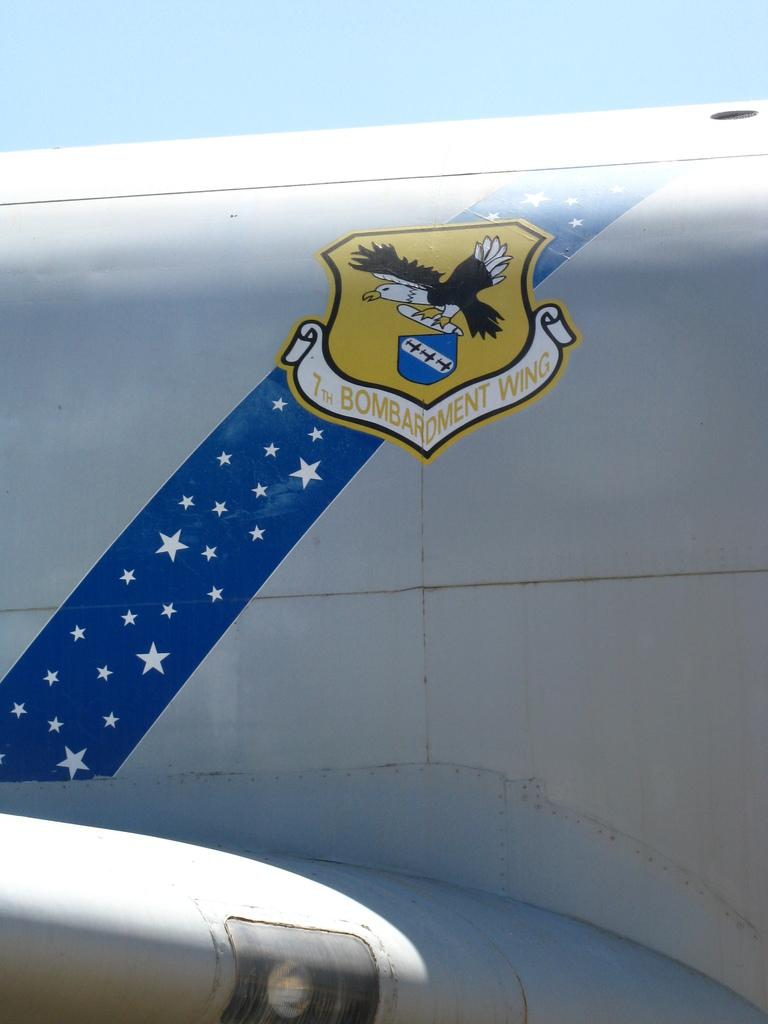<image>
Create a compact narrative representing the image presented. The emblem for the 7th Bombardment Wing included an eagle with a scroll in its talons. 